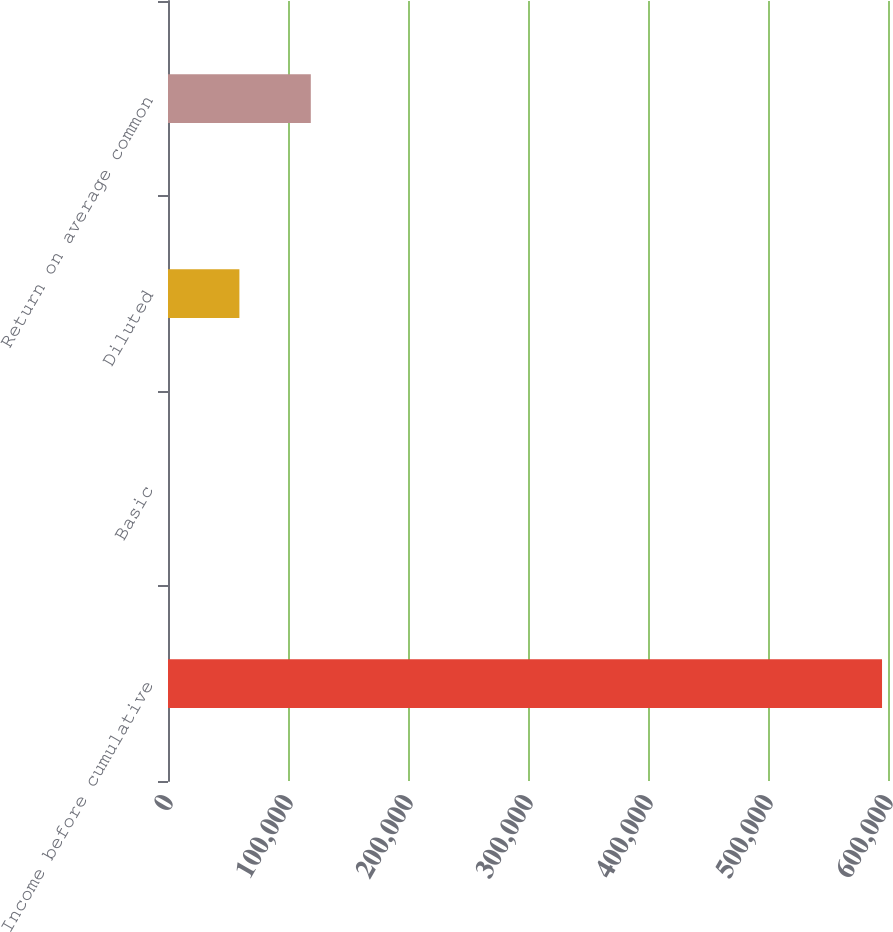Convert chart to OTSL. <chart><loc_0><loc_0><loc_500><loc_500><bar_chart><fcel>Income before cumulative<fcel>Basic<fcel>Diluted<fcel>Return on average common<nl><fcel>595026<fcel>2.25<fcel>59504.6<fcel>119007<nl></chart> 